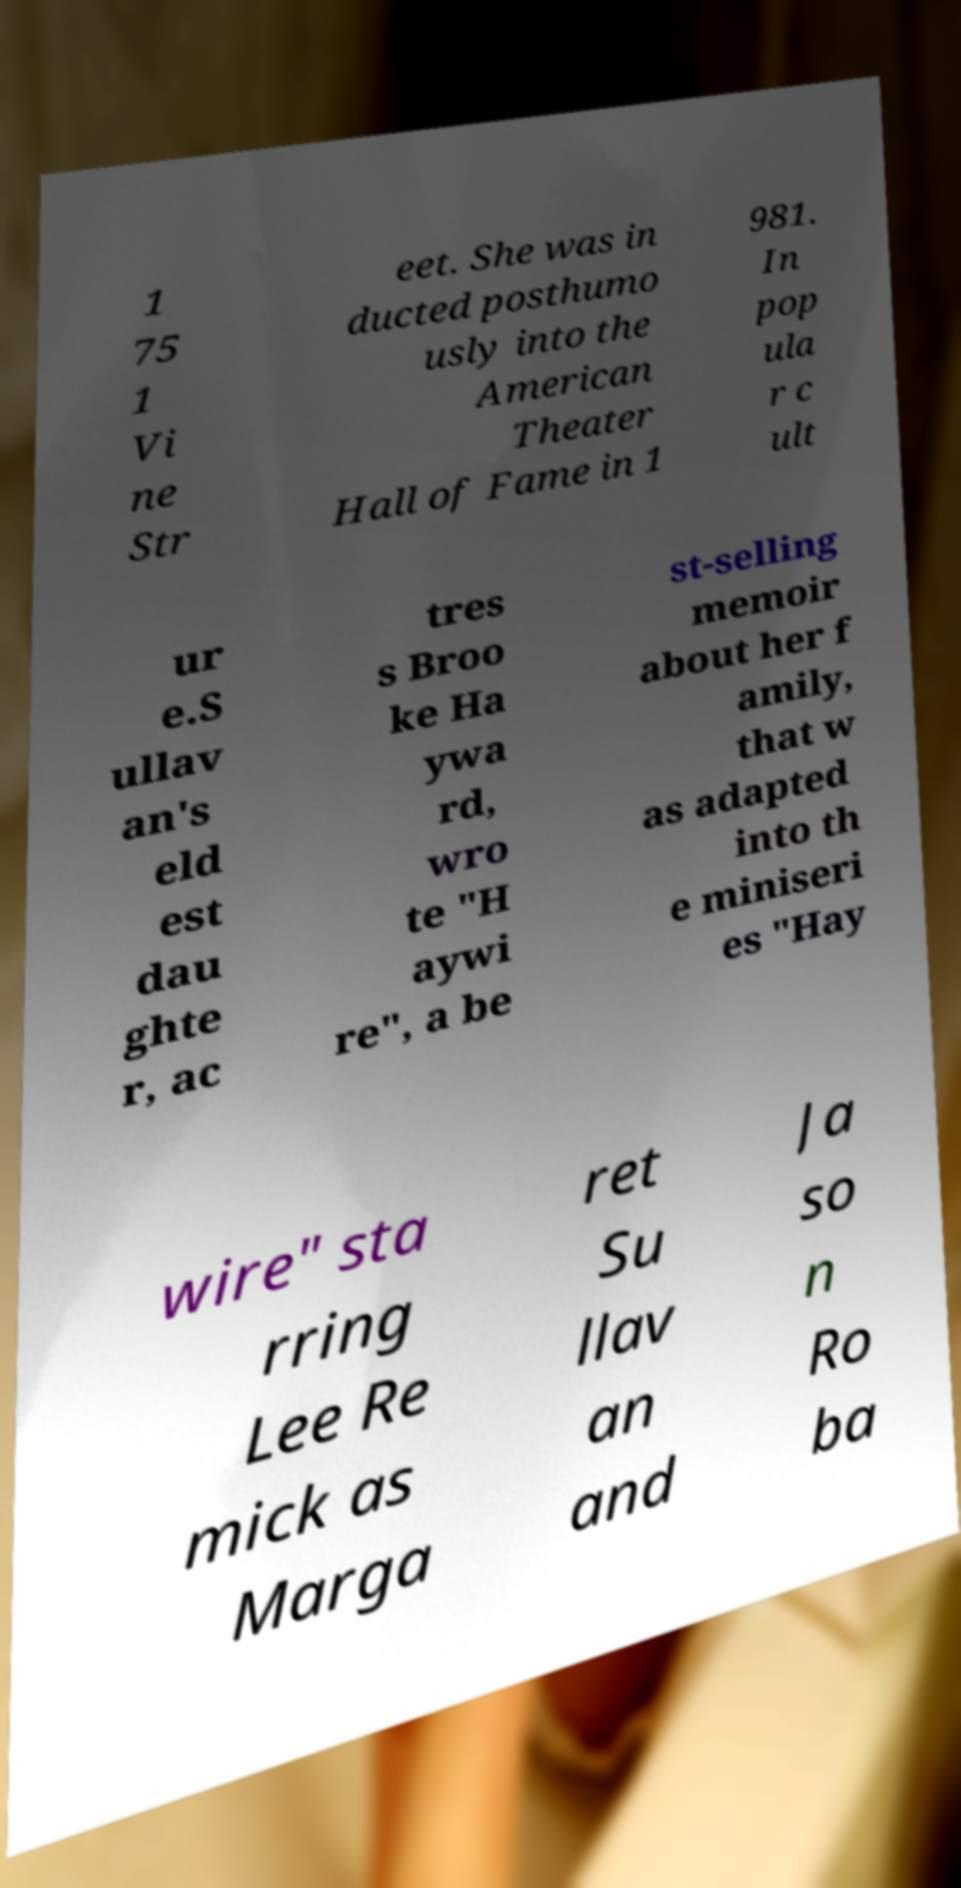Please identify and transcribe the text found in this image. 1 75 1 Vi ne Str eet. She was in ducted posthumo usly into the American Theater Hall of Fame in 1 981. In pop ula r c ult ur e.S ullav an's eld est dau ghte r, ac tres s Broo ke Ha ywa rd, wro te "H aywi re", a be st-selling memoir about her f amily, that w as adapted into th e miniseri es "Hay wire" sta rring Lee Re mick as Marga ret Su llav an and Ja so n Ro ba 